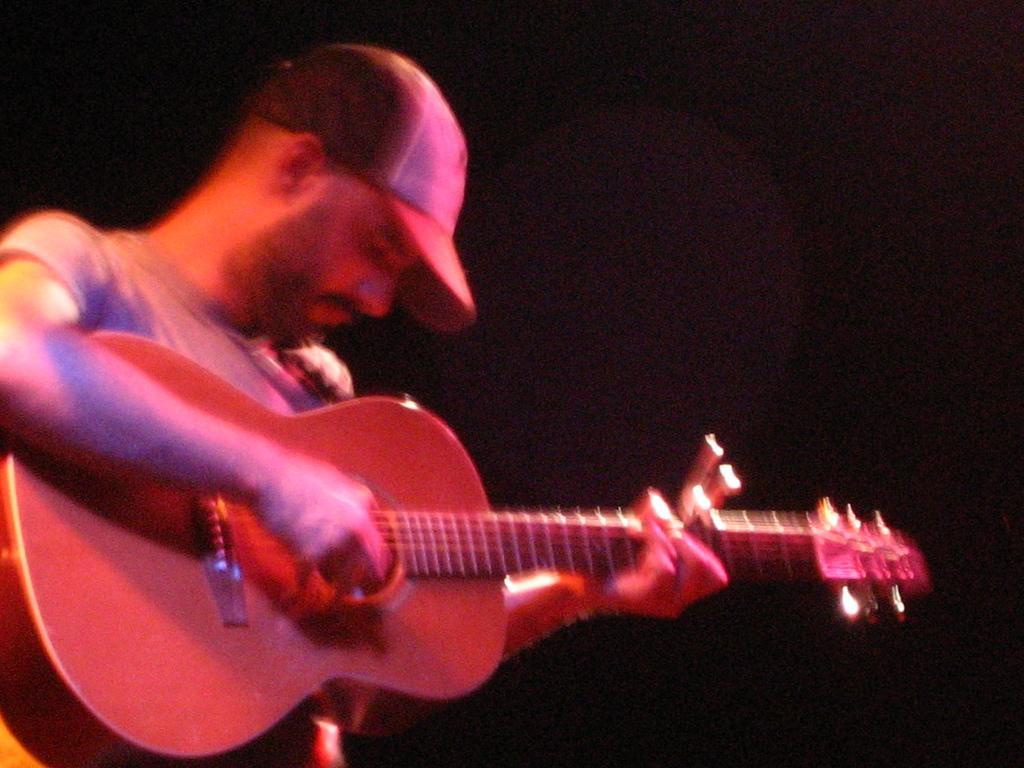Describe this image in one or two sentences. Here we can see a person playing a guitar and he is wearing a cap 